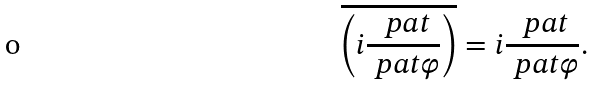Convert formula to latex. <formula><loc_0><loc_0><loc_500><loc_500>\overline { \left ( i \frac { \ p a t } { \ p a t \varphi } \right ) } = i \frac { \ p a t } { \ p a t \varphi } .</formula> 